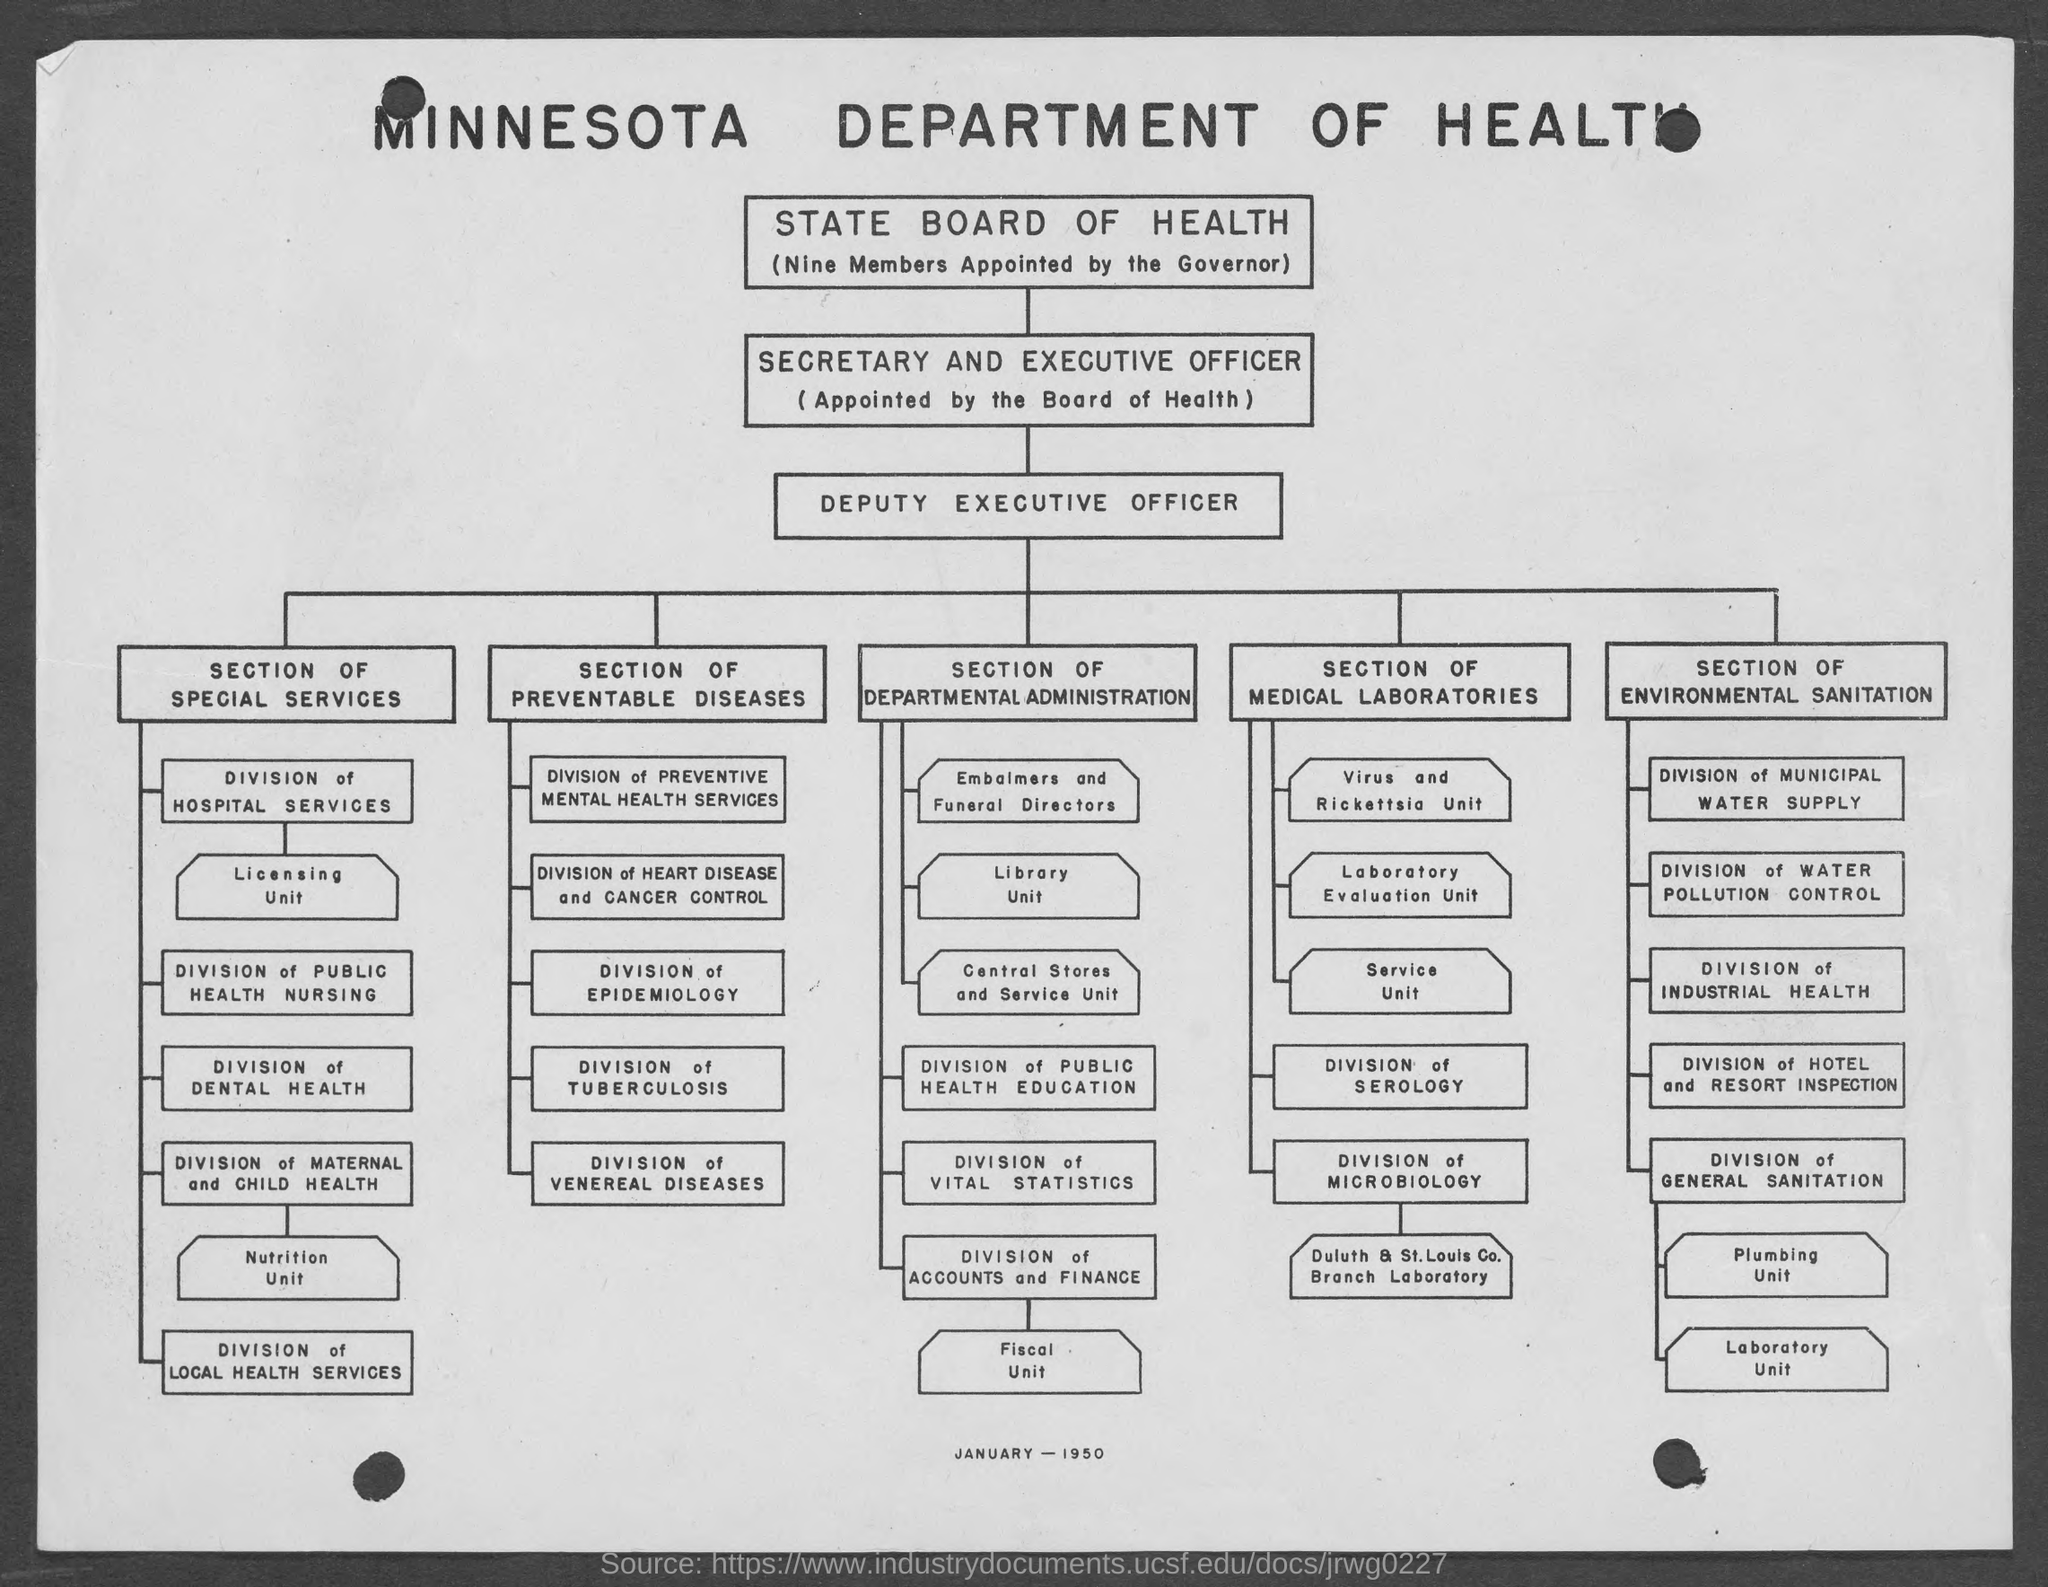Which department is mentioned?
Give a very brief answer. MINNESOTA DEPARTMENT OF HEALTH. How many members are appointed by the governor in state board of health?
Your response must be concise. Nine Members. Who is appointed by the Board of Health?
Your answer should be very brief. SECRETARY AND EXECUTIVE OFFICER. Under which section does Division of Dental health come?
Offer a terse response. SECTION OF SPECIAL SERVICES. For which month and year is this flowchart?
Offer a very short reply. JANUARY - 1950. 